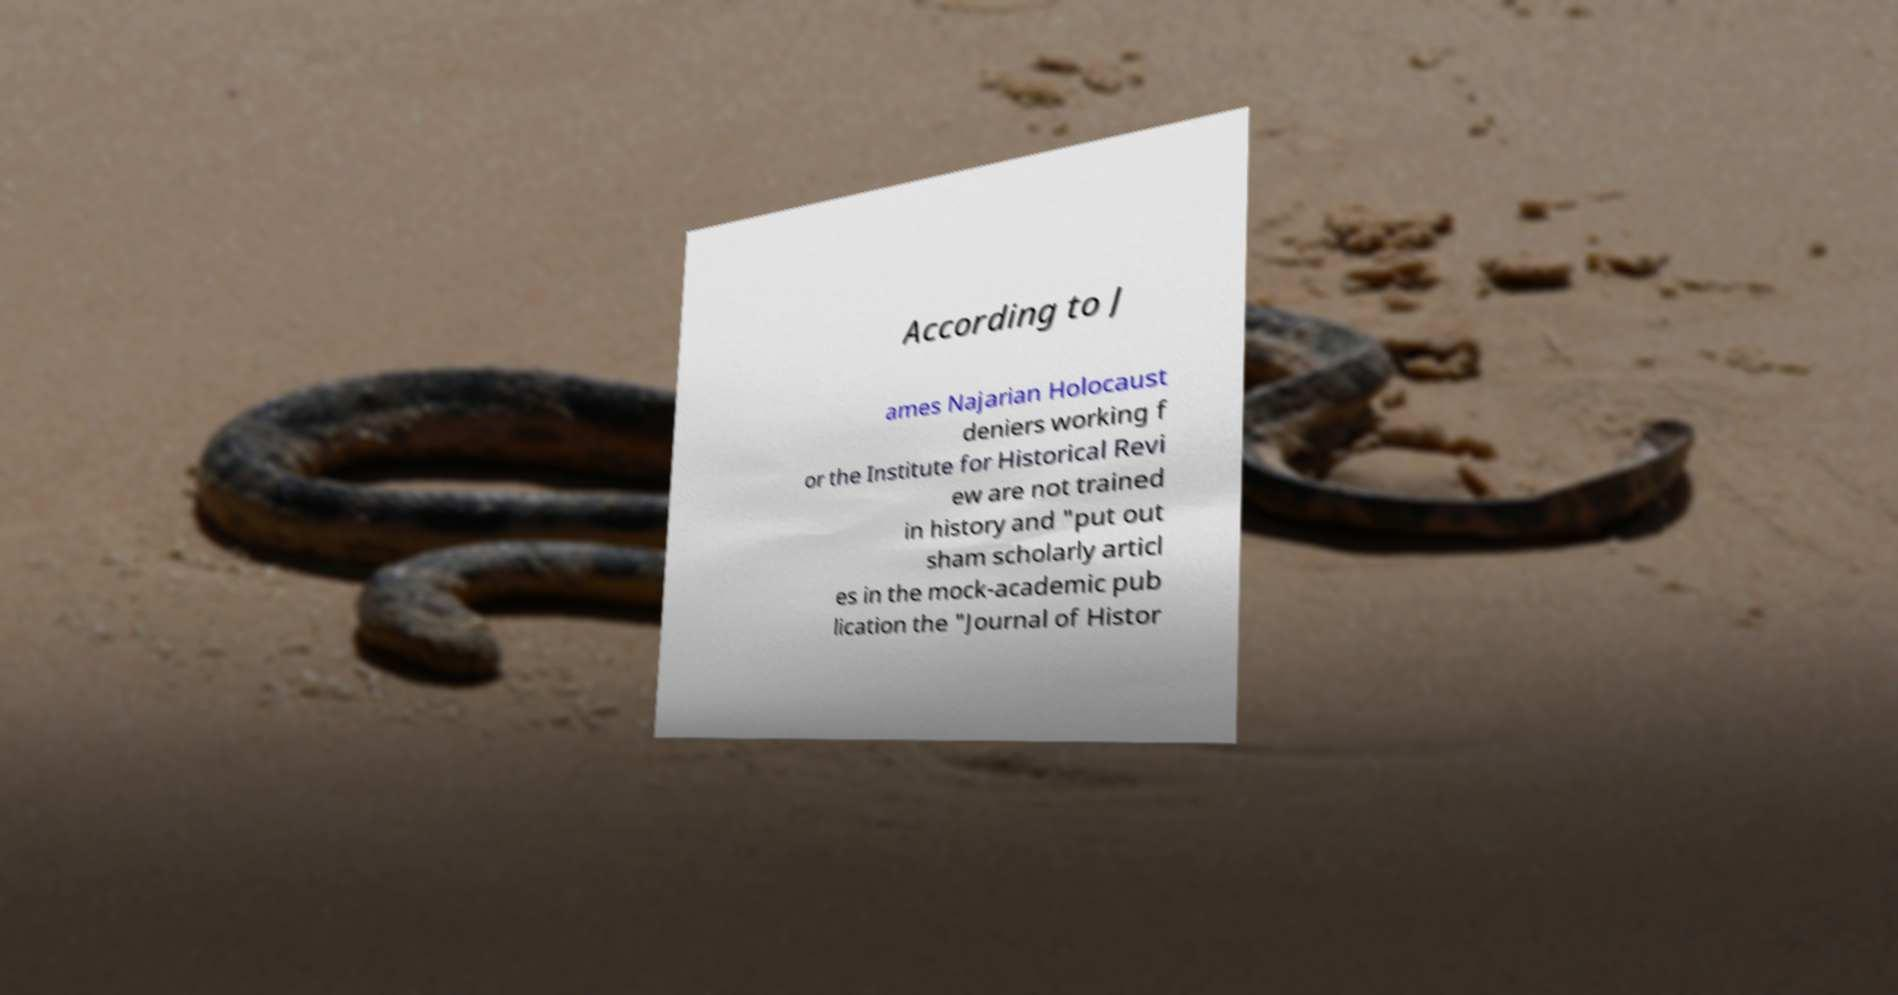I need the written content from this picture converted into text. Can you do that? According to J ames Najarian Holocaust deniers working f or the Institute for Historical Revi ew are not trained in history and "put out sham scholarly articl es in the mock-academic pub lication the "Journal of Histor 